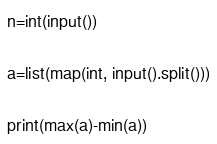Convert code to text. <code><loc_0><loc_0><loc_500><loc_500><_Python_>n=int(input())

a=list(map(int, input().split()))

print(max(a)-min(a))</code> 